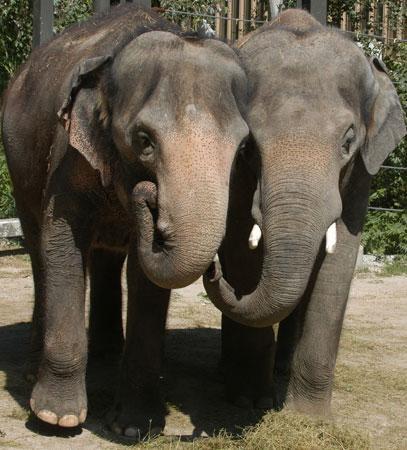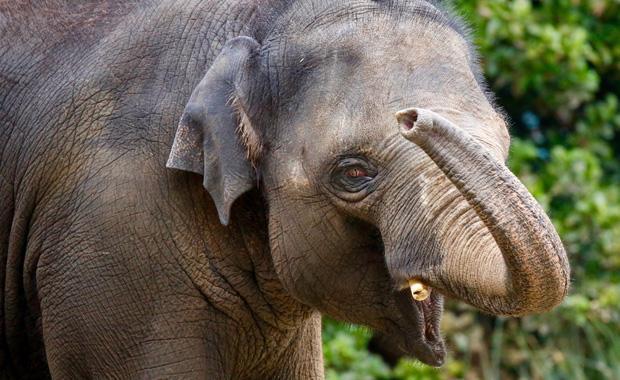The first image is the image on the left, the second image is the image on the right. Assess this claim about the two images: "All elephants shown have tusks and exactly one elephant faces the camera.". Correct or not? Answer yes or no. No. The first image is the image on the left, the second image is the image on the right. Examine the images to the left and right. Is the description "The left image contains two elephants touching their heads to each others." accurate? Answer yes or no. Yes. 